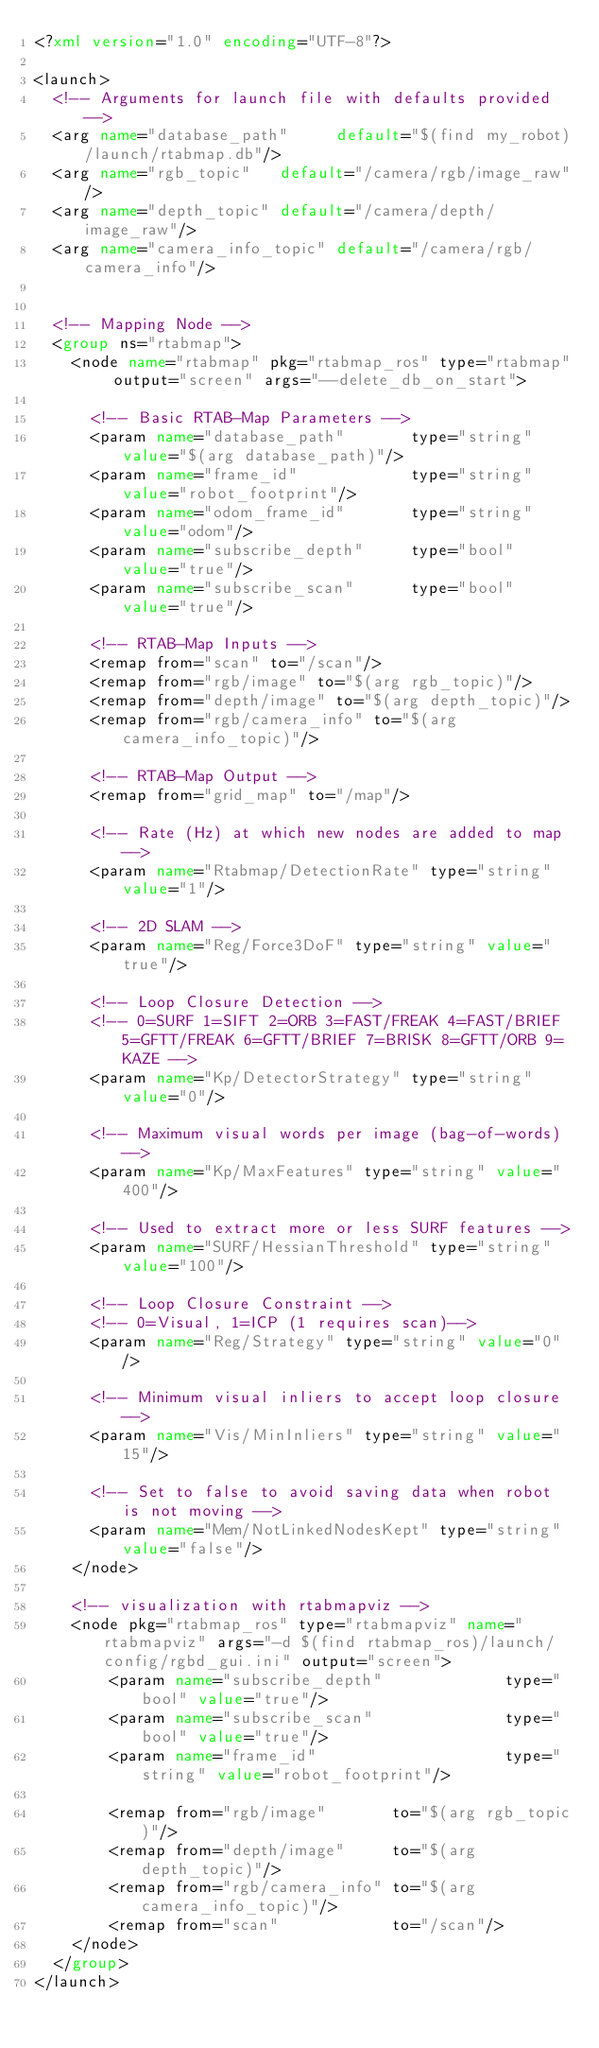<code> <loc_0><loc_0><loc_500><loc_500><_XML_><?xml version="1.0" encoding="UTF-8"?>

<launch>
  <!-- Arguments for launch file with defaults provided -->
  <arg name="database_path"     default="$(find my_robot)/launch/rtabmap.db"/>
  <arg name="rgb_topic"   default="/camera/rgb/image_raw"/>
  <arg name="depth_topic" default="/camera/depth/image_raw"/>
  <arg name="camera_info_topic" default="/camera/rgb/camera_info"/>  


  <!-- Mapping Node -->
  <group ns="rtabmap">
    <node name="rtabmap" pkg="rtabmap_ros" type="rtabmap" output="screen" args="--delete_db_on_start">

      <!-- Basic RTAB-Map Parameters -->
      <param name="database_path"       type="string" value="$(arg database_path)"/>
      <param name="frame_id"            type="string" value="robot_footprint"/>
      <param name="odom_frame_id"       type="string" value="odom"/>
      <param name="subscribe_depth"     type="bool"   value="true"/>
      <param name="subscribe_scan"      type="bool"   value="true"/>

      <!-- RTAB-Map Inputs -->
      <remap from="scan" to="/scan"/>
      <remap from="rgb/image" to="$(arg rgb_topic)"/>
      <remap from="depth/image" to="$(arg depth_topic)"/>
      <remap from="rgb/camera_info" to="$(arg camera_info_topic)"/>

      <!-- RTAB-Map Output -->
      <remap from="grid_map" to="/map"/>

      <!-- Rate (Hz) at which new nodes are added to map -->
      <param name="Rtabmap/DetectionRate" type="string" value="1"/>

      <!-- 2D SLAM -->
      <param name="Reg/Force3DoF" type="string" value="true"/>

      <!-- Loop Closure Detection -->
      <!-- 0=SURF 1=SIFT 2=ORB 3=FAST/FREAK 4=FAST/BRIEF 5=GFTT/FREAK 6=GFTT/BRIEF 7=BRISK 8=GFTT/ORB 9=KAZE -->
      <param name="Kp/DetectorStrategy" type="string" value="0"/>

      <!-- Maximum visual words per image (bag-of-words) -->
      <param name="Kp/MaxFeatures" type="string" value="400"/>

      <!-- Used to extract more or less SURF features -->
      <param name="SURF/HessianThreshold" type="string" value="100"/>

      <!-- Loop Closure Constraint -->
      <!-- 0=Visual, 1=ICP (1 requires scan)-->
      <param name="Reg/Strategy" type="string" value="0"/>

      <!-- Minimum visual inliers to accept loop closure -->
      <param name="Vis/MinInliers" type="string" value="15"/>

      <!-- Set to false to avoid saving data when robot is not moving -->
      <param name="Mem/NotLinkedNodesKept" type="string" value="false"/>
    </node>
    
    <!-- visualization with rtabmapviz -->
    <node pkg="rtabmap_ros" type="rtabmapviz" name="rtabmapviz" args="-d $(find rtabmap_ros)/launch/config/rgbd_gui.ini" output="screen">
        <param name="subscribe_depth"             type="bool" value="true"/>
        <param name="subscribe_scan"              type="bool" value="true"/>
        <param name="frame_id"                    type="string" value="robot_footprint"/>

        <remap from="rgb/image"       to="$(arg rgb_topic)"/>
        <remap from="depth/image"     to="$(arg depth_topic)"/>
        <remap from="rgb/camera_info" to="$(arg camera_info_topic)"/>
        <remap from="scan"            to="/scan"/>
    </node>
  </group>
</launch>
</code> 